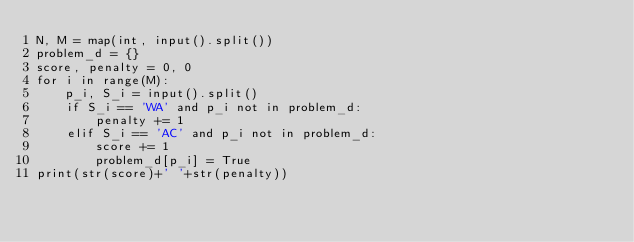Convert code to text. <code><loc_0><loc_0><loc_500><loc_500><_Python_>N, M = map(int, input().split())
problem_d = {}
score, penalty = 0, 0
for i in range(M):
	p_i, S_i = input().split()
	if S_i == 'WA' and p_i not in problem_d:
		penalty += 1
	elif S_i == 'AC' and p_i not in problem_d:
		score += 1
		problem_d[p_i] = True
print(str(score)+' '+str(penalty))</code> 